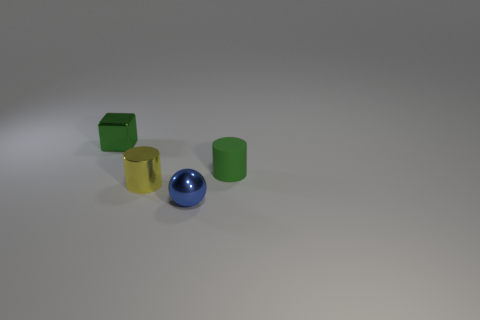Does the shiny cylinder have the same color as the tiny matte cylinder?
Keep it short and to the point. No. The blue thing is what shape?
Make the answer very short. Sphere. What is the material of the cylinder that is on the right side of the metal ball?
Your answer should be compact. Rubber. Are there any big matte objects of the same color as the shiny cylinder?
Give a very brief answer. No. The yellow metal object that is the same size as the metal sphere is what shape?
Your response must be concise. Cylinder. The shiny cube that is behind the sphere is what color?
Offer a terse response. Green. There is a tiny green thing in front of the small green metallic cube; are there any green objects that are to the left of it?
Offer a very short reply. Yes. What number of things are either cylinders that are on the left side of the small matte cylinder or small metallic cylinders?
Give a very brief answer. 1. Are there any other things that have the same size as the yellow metal object?
Provide a short and direct response. Yes. There is a small thing that is behind the green object on the right side of the green metallic block; what is it made of?
Offer a very short reply. Metal. 